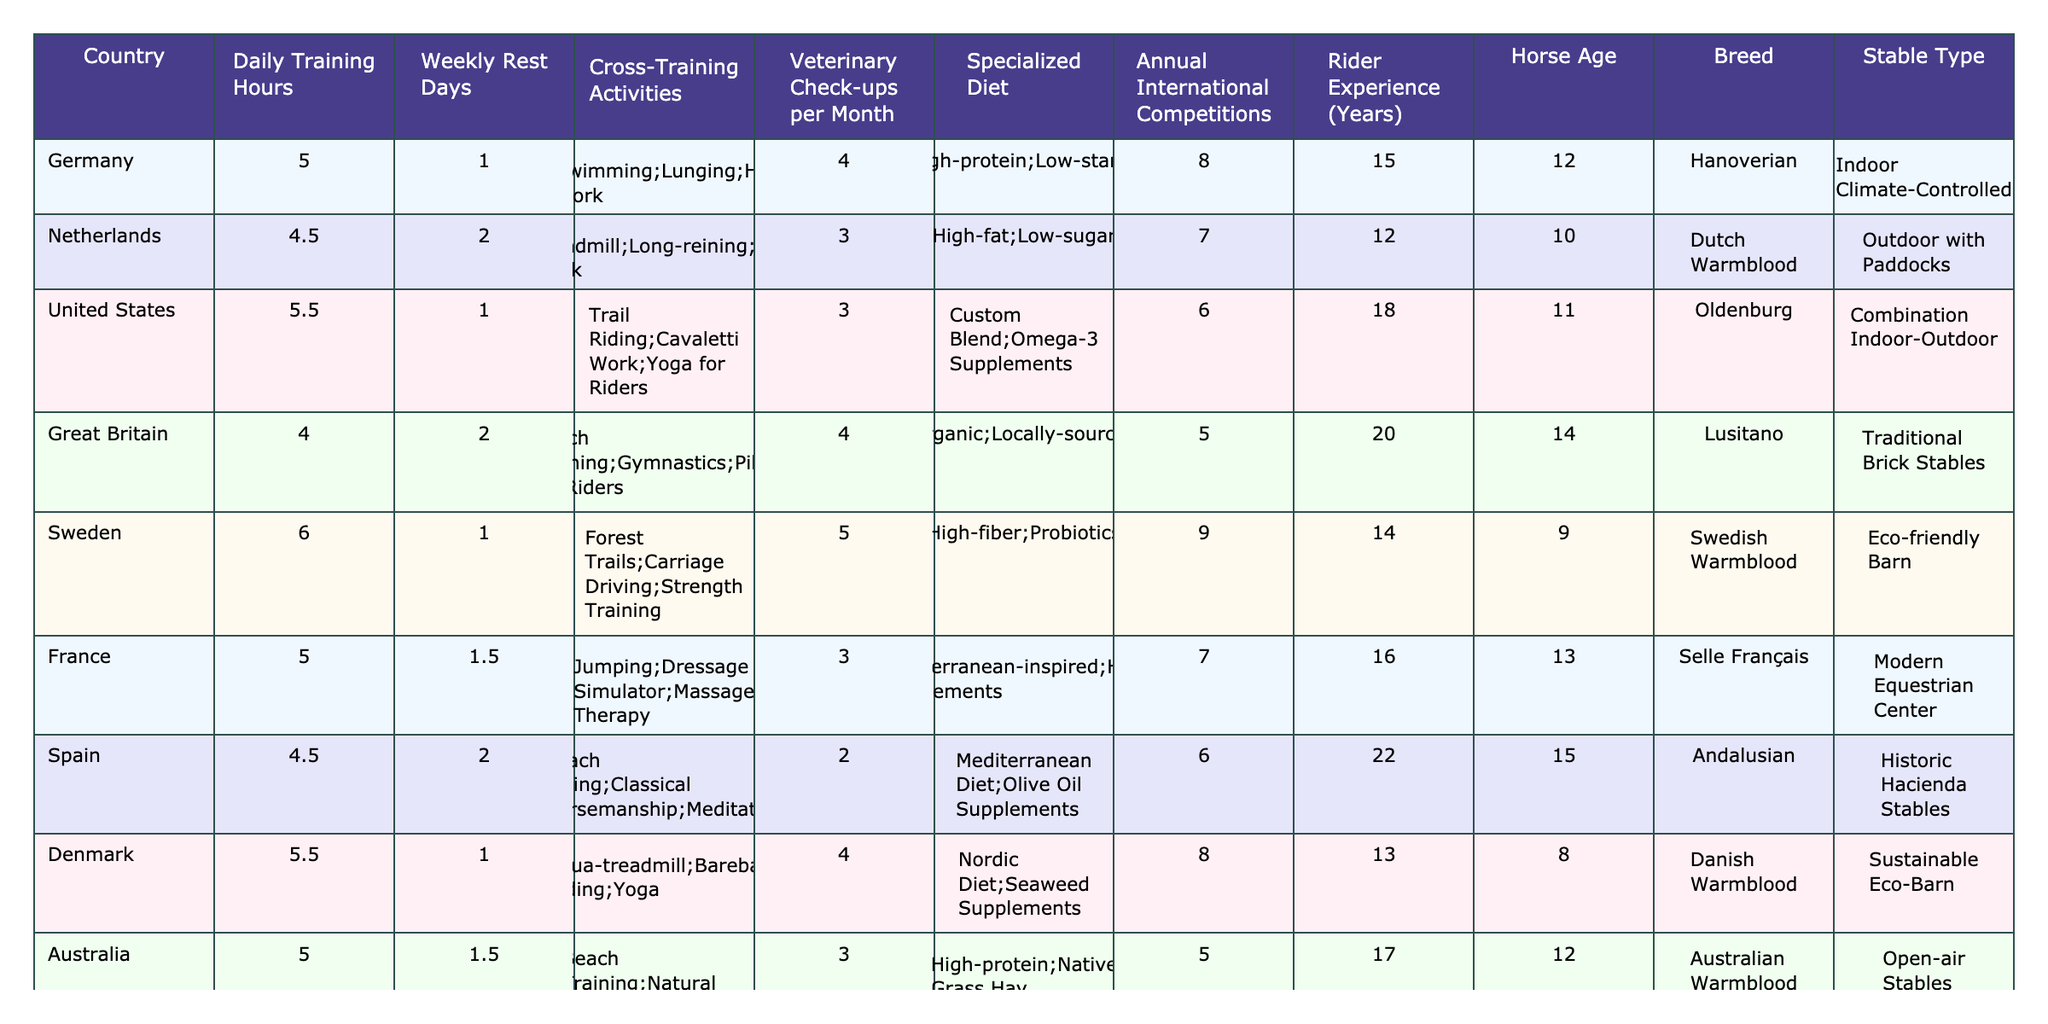What is the average daily training hours of the horses listed? The daily training hours for the horses are 5, 4.5, 5.5, 4, 6, 5, 4.5, 5.5, and 4. The sum of these hours is 46. Therefore, the average is 46 divided by 9, which equals approximately 5.11.
Answer: 5.11 Which country has the highest number of annual international competitions? Looking at the annual international competitions column, the values are 8, 7, 6, 5, 9, 7, 6, 8, and 4. The highest value is 9, which corresponds to Sweden.
Answer: Sweden How many veterinary check-ups does the German horse receive in a month? The veterinary check-ups per month for Germany is listed as 4.
Answer: 4 Is the Dutch Warmblood trained more frequently than the French Selle Français? The Dutch Warmblood has 4.5 daily training hours compared to the Selle Français's 5. This means the Dutch Warmblood is trained less frequently than the Selle Français.
Answer: No What is the total number of cross-training activities for horses from Spain and Japan? The cross-training activities for Spain are 3 and for Japan are also 3. Adding these together gives a total of 3 + 3 = 6.
Answer: 6 Which horse has the oldest age and what is that age? The ages of the horses are listed as 12, 10, 11, 14, 9, 13, 15, 8, and 11. The highest age is 22, which belongs to the horse from Spain.
Answer: 22 Does the rider from Great Britain have more experience than the rider from the Netherlands? The rider experience for Great Britain is 20 years, while for the Netherlands it is 12 years. Since 20 is greater than 12, the rider from Great Britain has more experience.
Answer: Yes What is the difference in age between the youngest and oldest horses? The youngest horse is from Sweden at age 9, and the oldest horse is from Spain at age 22. The difference is 22 - 9 = 13 years.
Answer: 13 Which type of stable is used for the horses in Denmark? The type of stable for the horse in Denmark is listed as a Sustainable Eco-Barn.
Answer: Sustainable Eco-Barn How many countries have horses that use a high-protein specialized diet? The countries with horses that have a high-protein diet are Germany, Australia, and one other country listed with this diet (France). That makes a total of 3 countries.
Answer: 3 